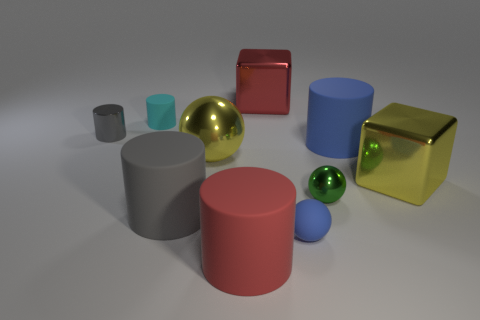What is the shape of the matte thing that is the same color as the tiny rubber ball?
Keep it short and to the point. Cylinder. There is a small object that is both to the left of the small blue object and right of the gray metal thing; what is its material?
Your answer should be very brief. Rubber. The large yellow object to the left of the big red cylinder has what shape?
Give a very brief answer. Sphere. What shape is the green metal thing behind the tiny matte object on the right side of the big sphere?
Your answer should be compact. Sphere. Is there another small object of the same shape as the tiny gray thing?
Provide a short and direct response. Yes. There is a red matte object that is the same size as the gray rubber object; what is its shape?
Make the answer very short. Cylinder. There is a sphere in front of the large rubber cylinder left of the yellow shiny ball; are there any cyan cylinders that are in front of it?
Offer a very short reply. No. Are there any yellow cubes that have the same size as the gray matte cylinder?
Your answer should be very brief. Yes. What size is the red object behind the small gray shiny cylinder?
Provide a succinct answer. Large. The metal ball that is on the left side of the metal object that is in front of the big object to the right of the blue rubber cylinder is what color?
Provide a succinct answer. Yellow. 